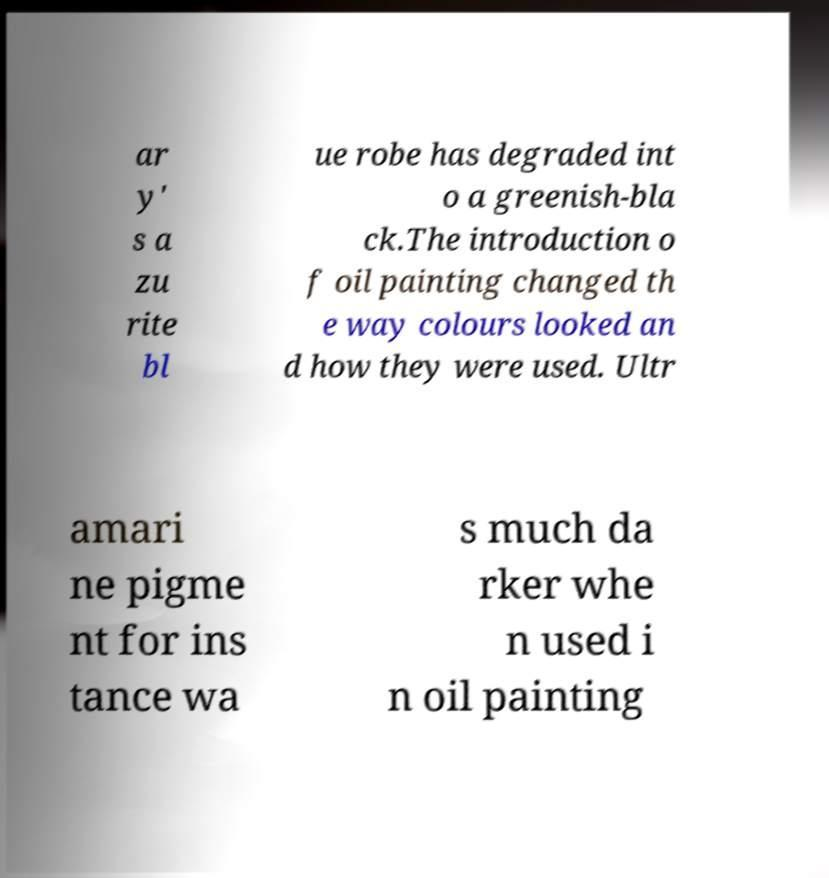Could you assist in decoding the text presented in this image and type it out clearly? ar y' s a zu rite bl ue robe has degraded int o a greenish-bla ck.The introduction o f oil painting changed th e way colours looked an d how they were used. Ultr amari ne pigme nt for ins tance wa s much da rker whe n used i n oil painting 